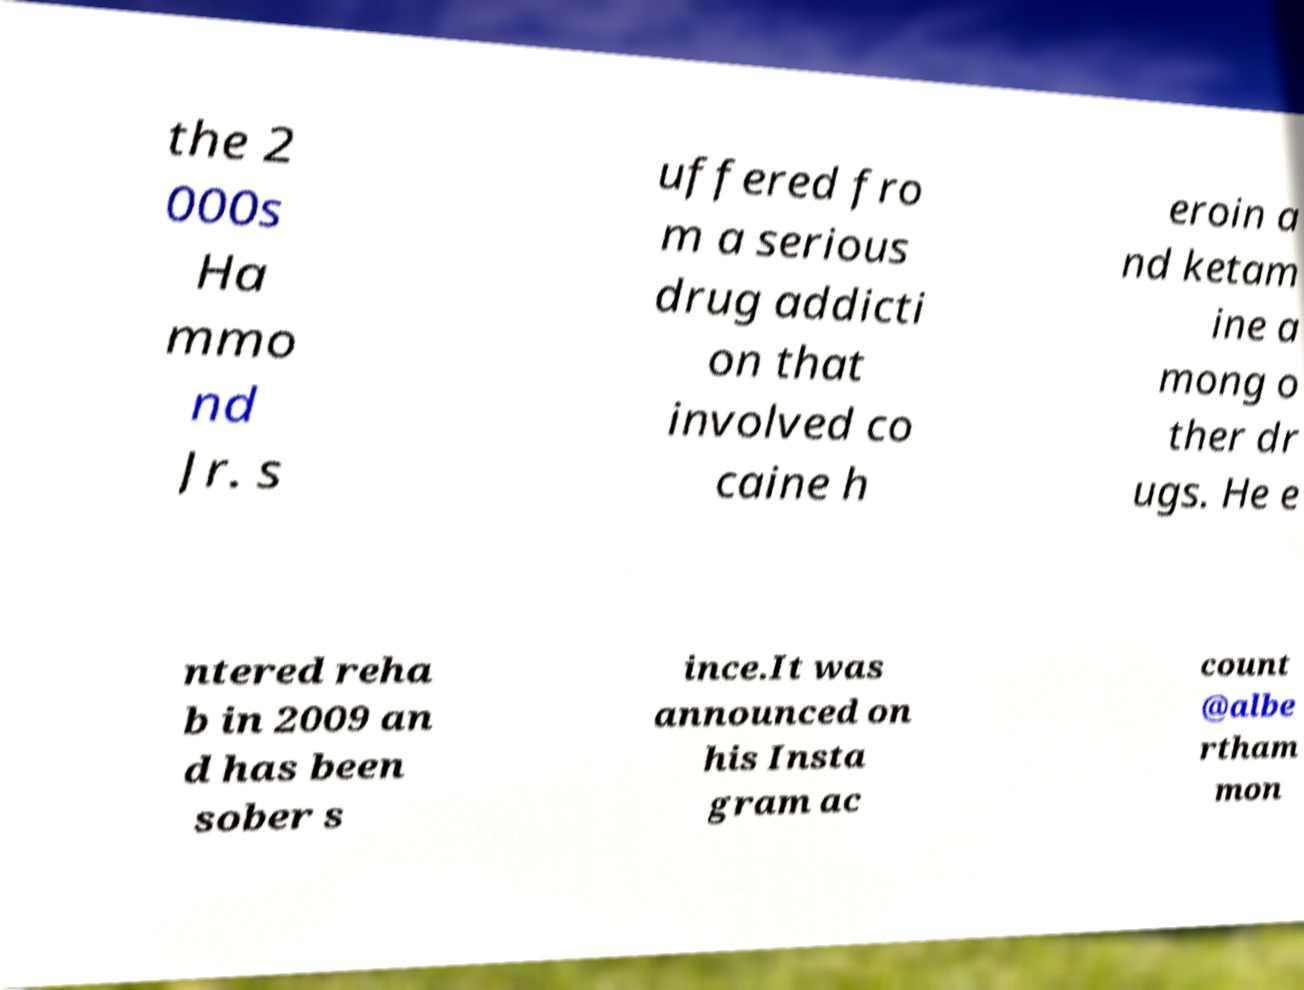Please identify and transcribe the text found in this image. the 2 000s Ha mmo nd Jr. s uffered fro m a serious drug addicti on that involved co caine h eroin a nd ketam ine a mong o ther dr ugs. He e ntered reha b in 2009 an d has been sober s ince.It was announced on his Insta gram ac count @albe rtham mon 